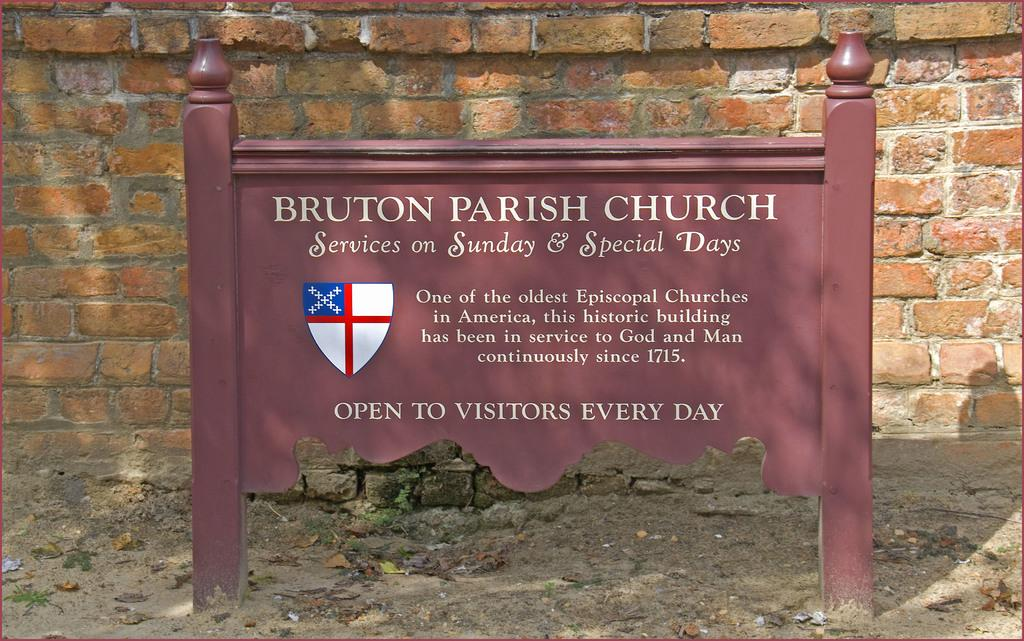What is the main object in the center of the picture? There is an iron board in the center of the picture. What is written or displayed on the iron board? There is text on the iron board. What can be seen in the background of the image? There is a brick wall in the background of the image. What type of natural elements are present at the bottom of the image? Dry leaves and soil are present at the bottom of the image. What type of beast can be seen roaming on the island in the image? There is no island or beast present in the image. What type of drug is being advertised on the iron board in the image? There is no drug mentioned or advertised on the iron board in the image. 